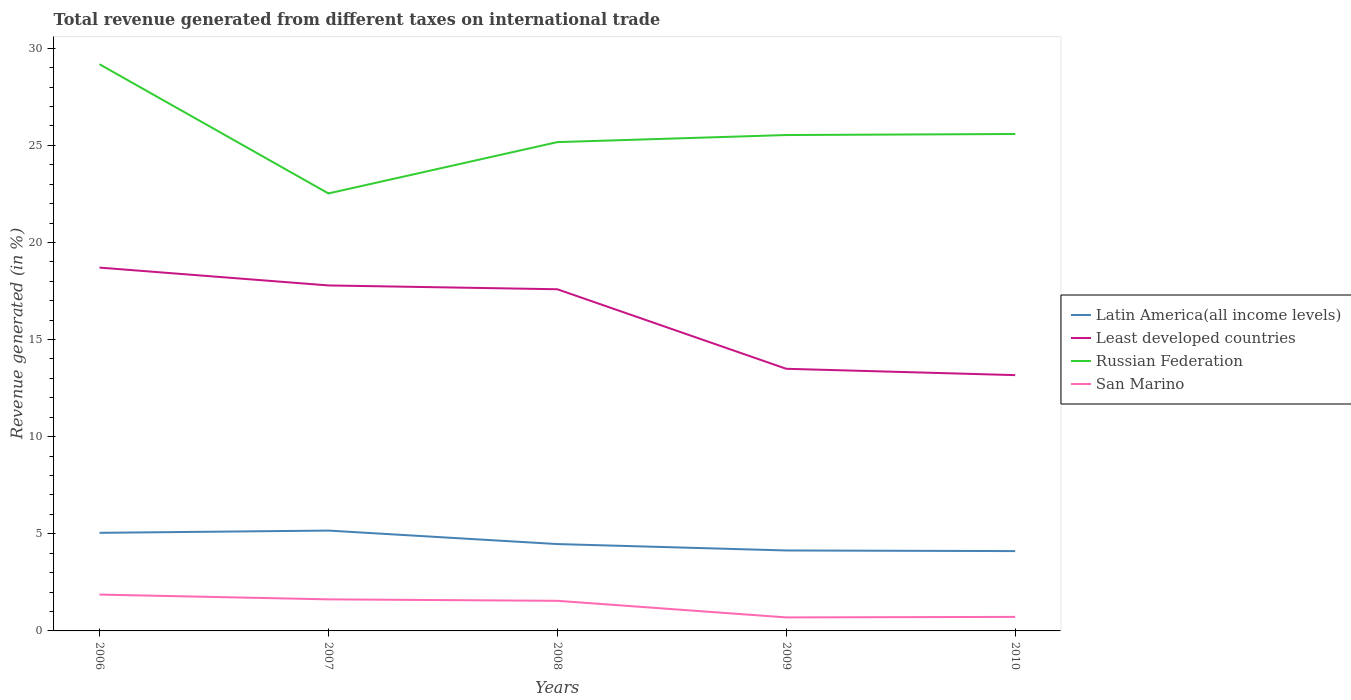Does the line corresponding to Latin America(all income levels) intersect with the line corresponding to San Marino?
Offer a very short reply. No. Is the number of lines equal to the number of legend labels?
Offer a very short reply. Yes. Across all years, what is the maximum total revenue generated in San Marino?
Ensure brevity in your answer.  0.7. In which year was the total revenue generated in Least developed countries maximum?
Provide a short and direct response. 2010. What is the total total revenue generated in Least developed countries in the graph?
Make the answer very short. 4.42. What is the difference between the highest and the second highest total revenue generated in Russian Federation?
Give a very brief answer. 6.65. How many years are there in the graph?
Provide a short and direct response. 5. Are the values on the major ticks of Y-axis written in scientific E-notation?
Ensure brevity in your answer.  No. What is the title of the graph?
Give a very brief answer. Total revenue generated from different taxes on international trade. Does "Mongolia" appear as one of the legend labels in the graph?
Offer a very short reply. No. What is the label or title of the Y-axis?
Make the answer very short. Revenue generated (in %). What is the Revenue generated (in %) in Latin America(all income levels) in 2006?
Provide a short and direct response. 5.05. What is the Revenue generated (in %) of Least developed countries in 2006?
Offer a terse response. 18.71. What is the Revenue generated (in %) in Russian Federation in 2006?
Your response must be concise. 29.18. What is the Revenue generated (in %) in San Marino in 2006?
Your answer should be compact. 1.87. What is the Revenue generated (in %) of Latin America(all income levels) in 2007?
Your answer should be compact. 5.17. What is the Revenue generated (in %) in Least developed countries in 2007?
Keep it short and to the point. 17.79. What is the Revenue generated (in %) of Russian Federation in 2007?
Your answer should be compact. 22.52. What is the Revenue generated (in %) of San Marino in 2007?
Your answer should be very brief. 1.62. What is the Revenue generated (in %) of Latin America(all income levels) in 2008?
Offer a terse response. 4.47. What is the Revenue generated (in %) in Least developed countries in 2008?
Give a very brief answer. 17.59. What is the Revenue generated (in %) in Russian Federation in 2008?
Offer a very short reply. 25.17. What is the Revenue generated (in %) of San Marino in 2008?
Your answer should be very brief. 1.55. What is the Revenue generated (in %) of Latin America(all income levels) in 2009?
Provide a succinct answer. 4.14. What is the Revenue generated (in %) of Least developed countries in 2009?
Make the answer very short. 13.5. What is the Revenue generated (in %) of Russian Federation in 2009?
Your answer should be very brief. 25.53. What is the Revenue generated (in %) of San Marino in 2009?
Make the answer very short. 0.7. What is the Revenue generated (in %) of Latin America(all income levels) in 2010?
Provide a succinct answer. 4.11. What is the Revenue generated (in %) of Least developed countries in 2010?
Make the answer very short. 13.17. What is the Revenue generated (in %) of Russian Federation in 2010?
Offer a terse response. 25.58. What is the Revenue generated (in %) in San Marino in 2010?
Give a very brief answer. 0.72. Across all years, what is the maximum Revenue generated (in %) of Latin America(all income levels)?
Ensure brevity in your answer.  5.17. Across all years, what is the maximum Revenue generated (in %) of Least developed countries?
Your answer should be compact. 18.71. Across all years, what is the maximum Revenue generated (in %) in Russian Federation?
Your response must be concise. 29.18. Across all years, what is the maximum Revenue generated (in %) in San Marino?
Your answer should be very brief. 1.87. Across all years, what is the minimum Revenue generated (in %) of Latin America(all income levels)?
Ensure brevity in your answer.  4.11. Across all years, what is the minimum Revenue generated (in %) in Least developed countries?
Give a very brief answer. 13.17. Across all years, what is the minimum Revenue generated (in %) of Russian Federation?
Your answer should be compact. 22.52. Across all years, what is the minimum Revenue generated (in %) of San Marino?
Offer a terse response. 0.7. What is the total Revenue generated (in %) in Latin America(all income levels) in the graph?
Keep it short and to the point. 22.94. What is the total Revenue generated (in %) of Least developed countries in the graph?
Give a very brief answer. 80.75. What is the total Revenue generated (in %) of Russian Federation in the graph?
Offer a very short reply. 127.98. What is the total Revenue generated (in %) in San Marino in the graph?
Ensure brevity in your answer.  6.47. What is the difference between the Revenue generated (in %) of Latin America(all income levels) in 2006 and that in 2007?
Provide a short and direct response. -0.12. What is the difference between the Revenue generated (in %) of Least developed countries in 2006 and that in 2007?
Make the answer very short. 0.92. What is the difference between the Revenue generated (in %) of Russian Federation in 2006 and that in 2007?
Offer a very short reply. 6.65. What is the difference between the Revenue generated (in %) of San Marino in 2006 and that in 2007?
Keep it short and to the point. 0.25. What is the difference between the Revenue generated (in %) of Latin America(all income levels) in 2006 and that in 2008?
Provide a short and direct response. 0.58. What is the difference between the Revenue generated (in %) of Least developed countries in 2006 and that in 2008?
Keep it short and to the point. 1.11. What is the difference between the Revenue generated (in %) of Russian Federation in 2006 and that in 2008?
Offer a very short reply. 4.01. What is the difference between the Revenue generated (in %) of San Marino in 2006 and that in 2008?
Provide a succinct answer. 0.32. What is the difference between the Revenue generated (in %) in Latin America(all income levels) in 2006 and that in 2009?
Make the answer very short. 0.91. What is the difference between the Revenue generated (in %) of Least developed countries in 2006 and that in 2009?
Your response must be concise. 5.21. What is the difference between the Revenue generated (in %) of Russian Federation in 2006 and that in 2009?
Your answer should be compact. 3.65. What is the difference between the Revenue generated (in %) of San Marino in 2006 and that in 2009?
Offer a very short reply. 1.18. What is the difference between the Revenue generated (in %) in Latin America(all income levels) in 2006 and that in 2010?
Offer a very short reply. 0.94. What is the difference between the Revenue generated (in %) in Least developed countries in 2006 and that in 2010?
Your answer should be very brief. 5.54. What is the difference between the Revenue generated (in %) of Russian Federation in 2006 and that in 2010?
Provide a succinct answer. 3.59. What is the difference between the Revenue generated (in %) of San Marino in 2006 and that in 2010?
Make the answer very short. 1.15. What is the difference between the Revenue generated (in %) of Latin America(all income levels) in 2007 and that in 2008?
Your response must be concise. 0.69. What is the difference between the Revenue generated (in %) of Least developed countries in 2007 and that in 2008?
Your response must be concise. 0.2. What is the difference between the Revenue generated (in %) of Russian Federation in 2007 and that in 2008?
Your answer should be very brief. -2.64. What is the difference between the Revenue generated (in %) in San Marino in 2007 and that in 2008?
Your answer should be compact. 0.07. What is the difference between the Revenue generated (in %) in Latin America(all income levels) in 2007 and that in 2009?
Provide a succinct answer. 1.02. What is the difference between the Revenue generated (in %) of Least developed countries in 2007 and that in 2009?
Provide a succinct answer. 4.29. What is the difference between the Revenue generated (in %) in Russian Federation in 2007 and that in 2009?
Give a very brief answer. -3.01. What is the difference between the Revenue generated (in %) in San Marino in 2007 and that in 2009?
Ensure brevity in your answer.  0.93. What is the difference between the Revenue generated (in %) of Latin America(all income levels) in 2007 and that in 2010?
Keep it short and to the point. 1.06. What is the difference between the Revenue generated (in %) of Least developed countries in 2007 and that in 2010?
Offer a terse response. 4.62. What is the difference between the Revenue generated (in %) in Russian Federation in 2007 and that in 2010?
Offer a very short reply. -3.06. What is the difference between the Revenue generated (in %) of San Marino in 2007 and that in 2010?
Make the answer very short. 0.9. What is the difference between the Revenue generated (in %) in Latin America(all income levels) in 2008 and that in 2009?
Give a very brief answer. 0.33. What is the difference between the Revenue generated (in %) in Least developed countries in 2008 and that in 2009?
Offer a very short reply. 4.09. What is the difference between the Revenue generated (in %) in Russian Federation in 2008 and that in 2009?
Make the answer very short. -0.36. What is the difference between the Revenue generated (in %) in San Marino in 2008 and that in 2009?
Your response must be concise. 0.85. What is the difference between the Revenue generated (in %) in Latin America(all income levels) in 2008 and that in 2010?
Your answer should be very brief. 0.36. What is the difference between the Revenue generated (in %) of Least developed countries in 2008 and that in 2010?
Make the answer very short. 4.42. What is the difference between the Revenue generated (in %) in Russian Federation in 2008 and that in 2010?
Provide a succinct answer. -0.42. What is the difference between the Revenue generated (in %) in San Marino in 2008 and that in 2010?
Give a very brief answer. 0.83. What is the difference between the Revenue generated (in %) in Latin America(all income levels) in 2009 and that in 2010?
Offer a very short reply. 0.03. What is the difference between the Revenue generated (in %) of Least developed countries in 2009 and that in 2010?
Make the answer very short. 0.33. What is the difference between the Revenue generated (in %) of Russian Federation in 2009 and that in 2010?
Provide a short and direct response. -0.05. What is the difference between the Revenue generated (in %) in San Marino in 2009 and that in 2010?
Give a very brief answer. -0.03. What is the difference between the Revenue generated (in %) of Latin America(all income levels) in 2006 and the Revenue generated (in %) of Least developed countries in 2007?
Your answer should be very brief. -12.74. What is the difference between the Revenue generated (in %) in Latin America(all income levels) in 2006 and the Revenue generated (in %) in Russian Federation in 2007?
Provide a short and direct response. -17.47. What is the difference between the Revenue generated (in %) of Latin America(all income levels) in 2006 and the Revenue generated (in %) of San Marino in 2007?
Your answer should be very brief. 3.43. What is the difference between the Revenue generated (in %) in Least developed countries in 2006 and the Revenue generated (in %) in Russian Federation in 2007?
Offer a very short reply. -3.82. What is the difference between the Revenue generated (in %) of Least developed countries in 2006 and the Revenue generated (in %) of San Marino in 2007?
Offer a very short reply. 17.08. What is the difference between the Revenue generated (in %) in Russian Federation in 2006 and the Revenue generated (in %) in San Marino in 2007?
Ensure brevity in your answer.  27.55. What is the difference between the Revenue generated (in %) in Latin America(all income levels) in 2006 and the Revenue generated (in %) in Least developed countries in 2008?
Your answer should be very brief. -12.54. What is the difference between the Revenue generated (in %) in Latin America(all income levels) in 2006 and the Revenue generated (in %) in Russian Federation in 2008?
Offer a terse response. -20.12. What is the difference between the Revenue generated (in %) of Least developed countries in 2006 and the Revenue generated (in %) of Russian Federation in 2008?
Provide a succinct answer. -6.46. What is the difference between the Revenue generated (in %) of Least developed countries in 2006 and the Revenue generated (in %) of San Marino in 2008?
Offer a terse response. 17.16. What is the difference between the Revenue generated (in %) in Russian Federation in 2006 and the Revenue generated (in %) in San Marino in 2008?
Your answer should be very brief. 27.63. What is the difference between the Revenue generated (in %) in Latin America(all income levels) in 2006 and the Revenue generated (in %) in Least developed countries in 2009?
Provide a short and direct response. -8.45. What is the difference between the Revenue generated (in %) in Latin America(all income levels) in 2006 and the Revenue generated (in %) in Russian Federation in 2009?
Make the answer very short. -20.48. What is the difference between the Revenue generated (in %) in Latin America(all income levels) in 2006 and the Revenue generated (in %) in San Marino in 2009?
Provide a succinct answer. 4.35. What is the difference between the Revenue generated (in %) in Least developed countries in 2006 and the Revenue generated (in %) in Russian Federation in 2009?
Your answer should be very brief. -6.83. What is the difference between the Revenue generated (in %) of Least developed countries in 2006 and the Revenue generated (in %) of San Marino in 2009?
Keep it short and to the point. 18.01. What is the difference between the Revenue generated (in %) in Russian Federation in 2006 and the Revenue generated (in %) in San Marino in 2009?
Offer a terse response. 28.48. What is the difference between the Revenue generated (in %) in Latin America(all income levels) in 2006 and the Revenue generated (in %) in Least developed countries in 2010?
Your answer should be very brief. -8.12. What is the difference between the Revenue generated (in %) of Latin America(all income levels) in 2006 and the Revenue generated (in %) of Russian Federation in 2010?
Provide a succinct answer. -20.53. What is the difference between the Revenue generated (in %) in Latin America(all income levels) in 2006 and the Revenue generated (in %) in San Marino in 2010?
Your response must be concise. 4.33. What is the difference between the Revenue generated (in %) of Least developed countries in 2006 and the Revenue generated (in %) of Russian Federation in 2010?
Offer a terse response. -6.88. What is the difference between the Revenue generated (in %) of Least developed countries in 2006 and the Revenue generated (in %) of San Marino in 2010?
Give a very brief answer. 17.98. What is the difference between the Revenue generated (in %) in Russian Federation in 2006 and the Revenue generated (in %) in San Marino in 2010?
Ensure brevity in your answer.  28.45. What is the difference between the Revenue generated (in %) of Latin America(all income levels) in 2007 and the Revenue generated (in %) of Least developed countries in 2008?
Ensure brevity in your answer.  -12.42. What is the difference between the Revenue generated (in %) in Latin America(all income levels) in 2007 and the Revenue generated (in %) in Russian Federation in 2008?
Your answer should be very brief. -20. What is the difference between the Revenue generated (in %) in Latin America(all income levels) in 2007 and the Revenue generated (in %) in San Marino in 2008?
Your response must be concise. 3.62. What is the difference between the Revenue generated (in %) of Least developed countries in 2007 and the Revenue generated (in %) of Russian Federation in 2008?
Your answer should be compact. -7.38. What is the difference between the Revenue generated (in %) of Least developed countries in 2007 and the Revenue generated (in %) of San Marino in 2008?
Your answer should be compact. 16.24. What is the difference between the Revenue generated (in %) of Russian Federation in 2007 and the Revenue generated (in %) of San Marino in 2008?
Your answer should be very brief. 20.97. What is the difference between the Revenue generated (in %) in Latin America(all income levels) in 2007 and the Revenue generated (in %) in Least developed countries in 2009?
Make the answer very short. -8.33. What is the difference between the Revenue generated (in %) in Latin America(all income levels) in 2007 and the Revenue generated (in %) in Russian Federation in 2009?
Provide a short and direct response. -20.36. What is the difference between the Revenue generated (in %) of Latin America(all income levels) in 2007 and the Revenue generated (in %) of San Marino in 2009?
Your answer should be compact. 4.47. What is the difference between the Revenue generated (in %) in Least developed countries in 2007 and the Revenue generated (in %) in Russian Federation in 2009?
Offer a very short reply. -7.74. What is the difference between the Revenue generated (in %) of Least developed countries in 2007 and the Revenue generated (in %) of San Marino in 2009?
Provide a succinct answer. 17.09. What is the difference between the Revenue generated (in %) of Russian Federation in 2007 and the Revenue generated (in %) of San Marino in 2009?
Keep it short and to the point. 21.83. What is the difference between the Revenue generated (in %) of Latin America(all income levels) in 2007 and the Revenue generated (in %) of Least developed countries in 2010?
Offer a very short reply. -8. What is the difference between the Revenue generated (in %) of Latin America(all income levels) in 2007 and the Revenue generated (in %) of Russian Federation in 2010?
Ensure brevity in your answer.  -20.42. What is the difference between the Revenue generated (in %) in Latin America(all income levels) in 2007 and the Revenue generated (in %) in San Marino in 2010?
Give a very brief answer. 4.44. What is the difference between the Revenue generated (in %) in Least developed countries in 2007 and the Revenue generated (in %) in Russian Federation in 2010?
Give a very brief answer. -7.8. What is the difference between the Revenue generated (in %) in Least developed countries in 2007 and the Revenue generated (in %) in San Marino in 2010?
Give a very brief answer. 17.06. What is the difference between the Revenue generated (in %) in Russian Federation in 2007 and the Revenue generated (in %) in San Marino in 2010?
Ensure brevity in your answer.  21.8. What is the difference between the Revenue generated (in %) in Latin America(all income levels) in 2008 and the Revenue generated (in %) in Least developed countries in 2009?
Ensure brevity in your answer.  -9.02. What is the difference between the Revenue generated (in %) of Latin America(all income levels) in 2008 and the Revenue generated (in %) of Russian Federation in 2009?
Your answer should be very brief. -21.06. What is the difference between the Revenue generated (in %) in Latin America(all income levels) in 2008 and the Revenue generated (in %) in San Marino in 2009?
Your answer should be compact. 3.78. What is the difference between the Revenue generated (in %) in Least developed countries in 2008 and the Revenue generated (in %) in Russian Federation in 2009?
Your answer should be very brief. -7.94. What is the difference between the Revenue generated (in %) of Least developed countries in 2008 and the Revenue generated (in %) of San Marino in 2009?
Your answer should be compact. 16.89. What is the difference between the Revenue generated (in %) of Russian Federation in 2008 and the Revenue generated (in %) of San Marino in 2009?
Offer a very short reply. 24.47. What is the difference between the Revenue generated (in %) of Latin America(all income levels) in 2008 and the Revenue generated (in %) of Least developed countries in 2010?
Ensure brevity in your answer.  -8.7. What is the difference between the Revenue generated (in %) of Latin America(all income levels) in 2008 and the Revenue generated (in %) of Russian Federation in 2010?
Keep it short and to the point. -21.11. What is the difference between the Revenue generated (in %) of Latin America(all income levels) in 2008 and the Revenue generated (in %) of San Marino in 2010?
Offer a terse response. 3.75. What is the difference between the Revenue generated (in %) in Least developed countries in 2008 and the Revenue generated (in %) in Russian Federation in 2010?
Keep it short and to the point. -7.99. What is the difference between the Revenue generated (in %) in Least developed countries in 2008 and the Revenue generated (in %) in San Marino in 2010?
Offer a terse response. 16.87. What is the difference between the Revenue generated (in %) of Russian Federation in 2008 and the Revenue generated (in %) of San Marino in 2010?
Ensure brevity in your answer.  24.44. What is the difference between the Revenue generated (in %) in Latin America(all income levels) in 2009 and the Revenue generated (in %) in Least developed countries in 2010?
Your answer should be very brief. -9.03. What is the difference between the Revenue generated (in %) of Latin America(all income levels) in 2009 and the Revenue generated (in %) of Russian Federation in 2010?
Your response must be concise. -21.44. What is the difference between the Revenue generated (in %) in Latin America(all income levels) in 2009 and the Revenue generated (in %) in San Marino in 2010?
Your answer should be very brief. 3.42. What is the difference between the Revenue generated (in %) of Least developed countries in 2009 and the Revenue generated (in %) of Russian Federation in 2010?
Your answer should be very brief. -12.09. What is the difference between the Revenue generated (in %) of Least developed countries in 2009 and the Revenue generated (in %) of San Marino in 2010?
Your response must be concise. 12.77. What is the difference between the Revenue generated (in %) of Russian Federation in 2009 and the Revenue generated (in %) of San Marino in 2010?
Give a very brief answer. 24.81. What is the average Revenue generated (in %) of Latin America(all income levels) per year?
Offer a very short reply. 4.59. What is the average Revenue generated (in %) in Least developed countries per year?
Keep it short and to the point. 16.15. What is the average Revenue generated (in %) of Russian Federation per year?
Keep it short and to the point. 25.6. What is the average Revenue generated (in %) of San Marino per year?
Your answer should be compact. 1.29. In the year 2006, what is the difference between the Revenue generated (in %) of Latin America(all income levels) and Revenue generated (in %) of Least developed countries?
Give a very brief answer. -13.66. In the year 2006, what is the difference between the Revenue generated (in %) in Latin America(all income levels) and Revenue generated (in %) in Russian Federation?
Keep it short and to the point. -24.13. In the year 2006, what is the difference between the Revenue generated (in %) in Latin America(all income levels) and Revenue generated (in %) in San Marino?
Provide a short and direct response. 3.18. In the year 2006, what is the difference between the Revenue generated (in %) in Least developed countries and Revenue generated (in %) in Russian Federation?
Offer a very short reply. -10.47. In the year 2006, what is the difference between the Revenue generated (in %) of Least developed countries and Revenue generated (in %) of San Marino?
Ensure brevity in your answer.  16.83. In the year 2006, what is the difference between the Revenue generated (in %) of Russian Federation and Revenue generated (in %) of San Marino?
Offer a very short reply. 27.3. In the year 2007, what is the difference between the Revenue generated (in %) in Latin America(all income levels) and Revenue generated (in %) in Least developed countries?
Offer a terse response. -12.62. In the year 2007, what is the difference between the Revenue generated (in %) of Latin America(all income levels) and Revenue generated (in %) of Russian Federation?
Your answer should be very brief. -17.36. In the year 2007, what is the difference between the Revenue generated (in %) in Latin America(all income levels) and Revenue generated (in %) in San Marino?
Make the answer very short. 3.54. In the year 2007, what is the difference between the Revenue generated (in %) of Least developed countries and Revenue generated (in %) of Russian Federation?
Offer a very short reply. -4.74. In the year 2007, what is the difference between the Revenue generated (in %) of Least developed countries and Revenue generated (in %) of San Marino?
Make the answer very short. 16.16. In the year 2007, what is the difference between the Revenue generated (in %) of Russian Federation and Revenue generated (in %) of San Marino?
Provide a succinct answer. 20.9. In the year 2008, what is the difference between the Revenue generated (in %) of Latin America(all income levels) and Revenue generated (in %) of Least developed countries?
Offer a very short reply. -13.12. In the year 2008, what is the difference between the Revenue generated (in %) in Latin America(all income levels) and Revenue generated (in %) in Russian Federation?
Keep it short and to the point. -20.69. In the year 2008, what is the difference between the Revenue generated (in %) in Latin America(all income levels) and Revenue generated (in %) in San Marino?
Provide a short and direct response. 2.92. In the year 2008, what is the difference between the Revenue generated (in %) of Least developed countries and Revenue generated (in %) of Russian Federation?
Your answer should be compact. -7.58. In the year 2008, what is the difference between the Revenue generated (in %) in Least developed countries and Revenue generated (in %) in San Marino?
Provide a short and direct response. 16.04. In the year 2008, what is the difference between the Revenue generated (in %) in Russian Federation and Revenue generated (in %) in San Marino?
Provide a succinct answer. 23.62. In the year 2009, what is the difference between the Revenue generated (in %) in Latin America(all income levels) and Revenue generated (in %) in Least developed countries?
Your answer should be compact. -9.35. In the year 2009, what is the difference between the Revenue generated (in %) in Latin America(all income levels) and Revenue generated (in %) in Russian Federation?
Give a very brief answer. -21.39. In the year 2009, what is the difference between the Revenue generated (in %) in Latin America(all income levels) and Revenue generated (in %) in San Marino?
Your response must be concise. 3.45. In the year 2009, what is the difference between the Revenue generated (in %) of Least developed countries and Revenue generated (in %) of Russian Federation?
Give a very brief answer. -12.03. In the year 2009, what is the difference between the Revenue generated (in %) of Least developed countries and Revenue generated (in %) of San Marino?
Ensure brevity in your answer.  12.8. In the year 2009, what is the difference between the Revenue generated (in %) of Russian Federation and Revenue generated (in %) of San Marino?
Give a very brief answer. 24.83. In the year 2010, what is the difference between the Revenue generated (in %) of Latin America(all income levels) and Revenue generated (in %) of Least developed countries?
Offer a terse response. -9.06. In the year 2010, what is the difference between the Revenue generated (in %) of Latin America(all income levels) and Revenue generated (in %) of Russian Federation?
Keep it short and to the point. -21.47. In the year 2010, what is the difference between the Revenue generated (in %) in Latin America(all income levels) and Revenue generated (in %) in San Marino?
Provide a short and direct response. 3.39. In the year 2010, what is the difference between the Revenue generated (in %) of Least developed countries and Revenue generated (in %) of Russian Federation?
Your response must be concise. -12.41. In the year 2010, what is the difference between the Revenue generated (in %) in Least developed countries and Revenue generated (in %) in San Marino?
Offer a very short reply. 12.45. In the year 2010, what is the difference between the Revenue generated (in %) in Russian Federation and Revenue generated (in %) in San Marino?
Provide a short and direct response. 24.86. What is the ratio of the Revenue generated (in %) in Latin America(all income levels) in 2006 to that in 2007?
Keep it short and to the point. 0.98. What is the ratio of the Revenue generated (in %) in Least developed countries in 2006 to that in 2007?
Ensure brevity in your answer.  1.05. What is the ratio of the Revenue generated (in %) in Russian Federation in 2006 to that in 2007?
Your response must be concise. 1.3. What is the ratio of the Revenue generated (in %) in San Marino in 2006 to that in 2007?
Give a very brief answer. 1.15. What is the ratio of the Revenue generated (in %) in Latin America(all income levels) in 2006 to that in 2008?
Your answer should be very brief. 1.13. What is the ratio of the Revenue generated (in %) of Least developed countries in 2006 to that in 2008?
Your answer should be very brief. 1.06. What is the ratio of the Revenue generated (in %) of Russian Federation in 2006 to that in 2008?
Keep it short and to the point. 1.16. What is the ratio of the Revenue generated (in %) in San Marino in 2006 to that in 2008?
Provide a succinct answer. 1.21. What is the ratio of the Revenue generated (in %) in Latin America(all income levels) in 2006 to that in 2009?
Provide a short and direct response. 1.22. What is the ratio of the Revenue generated (in %) in Least developed countries in 2006 to that in 2009?
Give a very brief answer. 1.39. What is the ratio of the Revenue generated (in %) of Russian Federation in 2006 to that in 2009?
Give a very brief answer. 1.14. What is the ratio of the Revenue generated (in %) in San Marino in 2006 to that in 2009?
Offer a very short reply. 2.69. What is the ratio of the Revenue generated (in %) of Latin America(all income levels) in 2006 to that in 2010?
Your answer should be compact. 1.23. What is the ratio of the Revenue generated (in %) of Least developed countries in 2006 to that in 2010?
Make the answer very short. 1.42. What is the ratio of the Revenue generated (in %) of Russian Federation in 2006 to that in 2010?
Provide a succinct answer. 1.14. What is the ratio of the Revenue generated (in %) of San Marino in 2006 to that in 2010?
Ensure brevity in your answer.  2.59. What is the ratio of the Revenue generated (in %) in Latin America(all income levels) in 2007 to that in 2008?
Your answer should be compact. 1.16. What is the ratio of the Revenue generated (in %) of Least developed countries in 2007 to that in 2008?
Provide a short and direct response. 1.01. What is the ratio of the Revenue generated (in %) of Russian Federation in 2007 to that in 2008?
Offer a terse response. 0.9. What is the ratio of the Revenue generated (in %) of San Marino in 2007 to that in 2008?
Your answer should be very brief. 1.05. What is the ratio of the Revenue generated (in %) in Latin America(all income levels) in 2007 to that in 2009?
Make the answer very short. 1.25. What is the ratio of the Revenue generated (in %) of Least developed countries in 2007 to that in 2009?
Your answer should be very brief. 1.32. What is the ratio of the Revenue generated (in %) of Russian Federation in 2007 to that in 2009?
Offer a very short reply. 0.88. What is the ratio of the Revenue generated (in %) of San Marino in 2007 to that in 2009?
Your answer should be very brief. 2.33. What is the ratio of the Revenue generated (in %) in Latin America(all income levels) in 2007 to that in 2010?
Offer a very short reply. 1.26. What is the ratio of the Revenue generated (in %) of Least developed countries in 2007 to that in 2010?
Ensure brevity in your answer.  1.35. What is the ratio of the Revenue generated (in %) in Russian Federation in 2007 to that in 2010?
Provide a short and direct response. 0.88. What is the ratio of the Revenue generated (in %) in San Marino in 2007 to that in 2010?
Offer a very short reply. 2.25. What is the ratio of the Revenue generated (in %) of Latin America(all income levels) in 2008 to that in 2009?
Provide a short and direct response. 1.08. What is the ratio of the Revenue generated (in %) of Least developed countries in 2008 to that in 2009?
Your answer should be compact. 1.3. What is the ratio of the Revenue generated (in %) in Russian Federation in 2008 to that in 2009?
Offer a terse response. 0.99. What is the ratio of the Revenue generated (in %) in San Marino in 2008 to that in 2009?
Make the answer very short. 2.23. What is the ratio of the Revenue generated (in %) of Latin America(all income levels) in 2008 to that in 2010?
Offer a terse response. 1.09. What is the ratio of the Revenue generated (in %) of Least developed countries in 2008 to that in 2010?
Offer a very short reply. 1.34. What is the ratio of the Revenue generated (in %) of Russian Federation in 2008 to that in 2010?
Give a very brief answer. 0.98. What is the ratio of the Revenue generated (in %) of San Marino in 2008 to that in 2010?
Provide a short and direct response. 2.15. What is the ratio of the Revenue generated (in %) of Latin America(all income levels) in 2009 to that in 2010?
Your answer should be compact. 1.01. What is the ratio of the Revenue generated (in %) in Least developed countries in 2009 to that in 2010?
Your response must be concise. 1.02. What is the ratio of the Revenue generated (in %) in Russian Federation in 2009 to that in 2010?
Your answer should be very brief. 1. What is the ratio of the Revenue generated (in %) in San Marino in 2009 to that in 2010?
Offer a very short reply. 0.96. What is the difference between the highest and the second highest Revenue generated (in %) of Latin America(all income levels)?
Your answer should be compact. 0.12. What is the difference between the highest and the second highest Revenue generated (in %) in Least developed countries?
Your response must be concise. 0.92. What is the difference between the highest and the second highest Revenue generated (in %) in Russian Federation?
Your response must be concise. 3.59. What is the difference between the highest and the second highest Revenue generated (in %) of San Marino?
Your answer should be compact. 0.25. What is the difference between the highest and the lowest Revenue generated (in %) in Latin America(all income levels)?
Your response must be concise. 1.06. What is the difference between the highest and the lowest Revenue generated (in %) of Least developed countries?
Give a very brief answer. 5.54. What is the difference between the highest and the lowest Revenue generated (in %) of Russian Federation?
Provide a short and direct response. 6.65. What is the difference between the highest and the lowest Revenue generated (in %) in San Marino?
Your response must be concise. 1.18. 